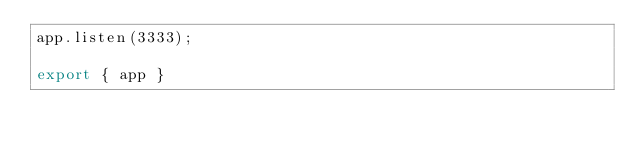<code> <loc_0><loc_0><loc_500><loc_500><_TypeScript_>app.listen(3333);

export { app }</code> 